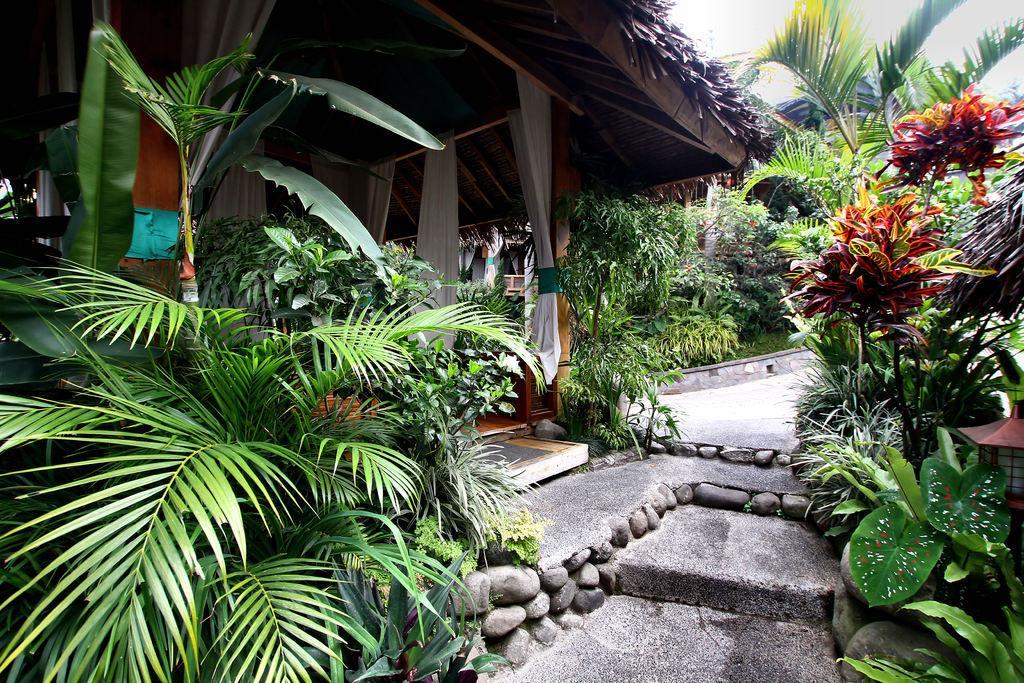Could you give a brief overview of what you see in this image? In the image we can see some plants, trees and sheds. In the top right corner of the image we can see the sky. 